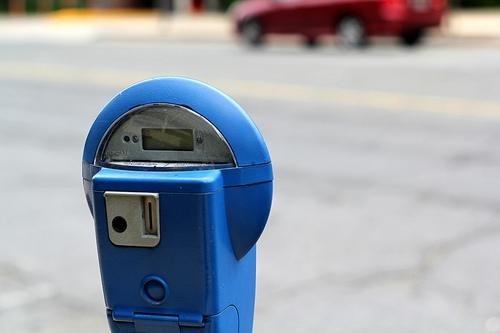Find and describe an object that is out of focus and its dimensions. The blurry red car in the background has dimensions Width:254 Height:254. Briefly describe the sentiment evoked by the image. The image evokes a feeling of a regular city scene and the mundane nature of parking meters. Provide a brief overview of the interactions between the objects in the image. The parking meter stands on the sidewalk beside the city street, while a blurry red car is parked across the street with its wheel and other details visible. Which object in the image has a contemporary design, and what are its dimensions? The contemporary-designed parking meter has dimensions Width:200 Height:200. What is the primary object of this image and the color of it? The primary object is a blue parking meter. Explain if the image is of high quality or not, and why you think so. The image seems to be of mixed quality, with different objects having different levels of focus and sharpness. Count the number of different car-related objects present in the image. There are 6 car-related objects in the image. Does the blue car have a flat tire in the background? There is no blue car in the background, there is a red car in the background. Select the most appropriate description for the car in the image: a) A clear red car; b) A blurry red car; c) A blue car; d) A black car A blurry red car What is the color of the stripe in the road? Yellow Provide a short and concise caption for the image. Blue parking meter and blurry red car Explain the event happening in the image. A parking meter is in use on a city street. What is the function of the coin slot on the parking meter? To insert coins for the parking fee Is there any visible text on the parking meter screen? No What is parked across the street from the parking meter? A red car Identify the round object on the wheel of the red car. Hub cap Can you see a person standing next to the silver coin slot? There is no mention of a person in the image data, only a silver coin slot on the parking meter. Is the red car parked or moving? Parked Describe the appearance of the parking meter screen. Blank Can you find a cat sitting on the light grey street? There is no mention of a cat or any other animal in the image data, only a light grey street. What color is the parking meter in the image? Blue What is the yellow element that can be seen on the image? A yellow road line Choose the correct statement: a) A red car is driving down the street; b) A parking meter is alongside a city street; c) A blue parking meter is on the grass A parking meter is alongside a city street Does the orange traffic cone beside the parking meter have any signs on it? There is no mention of an orange traffic cone or any signs in the image data. Is the green parking meter display showing any time left? There is no green parking meter in the image, the parking meter is blue, and its screen is blank. Describe the scene of the image in a single sentence. A blue parking meter is visible on the sidewalk with a blurry red car parked on the street in the background. What shape is the top part of the parking meter? Curved or rounded Is the purple bus behind the yellow road line visible? There is no mention of a purple bus or any vehicle other than the red car in the image data. Describe the texture of the street. Light grey What object can be found on the red car's wheel? A hub cap 